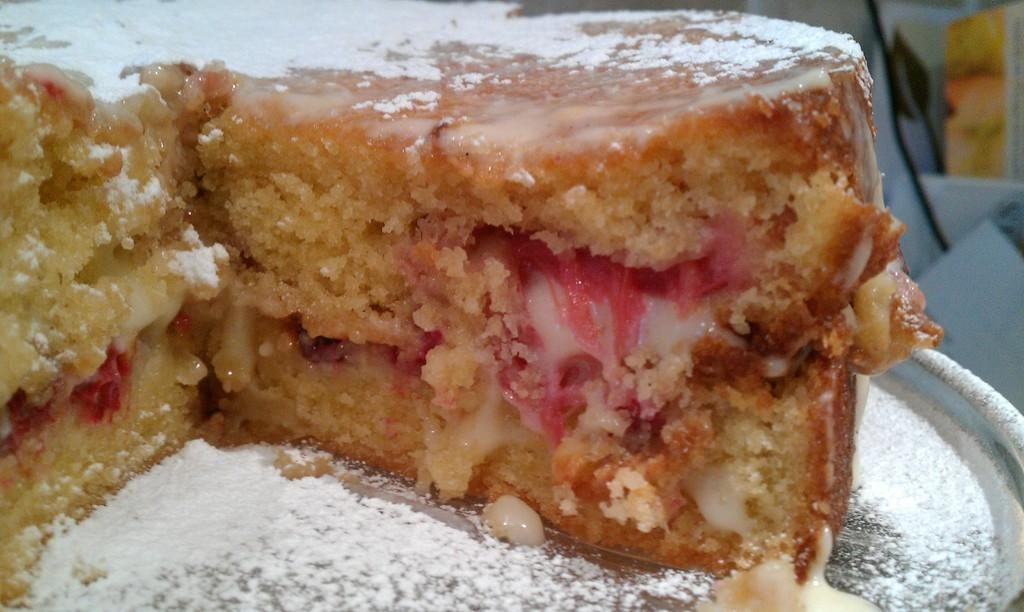What is the main subject of the image? There is a food item on a plate in the image. How many ants are crawling on the food item in the image? There is no mention of ants in the image, so it is not possible to answer that question. 